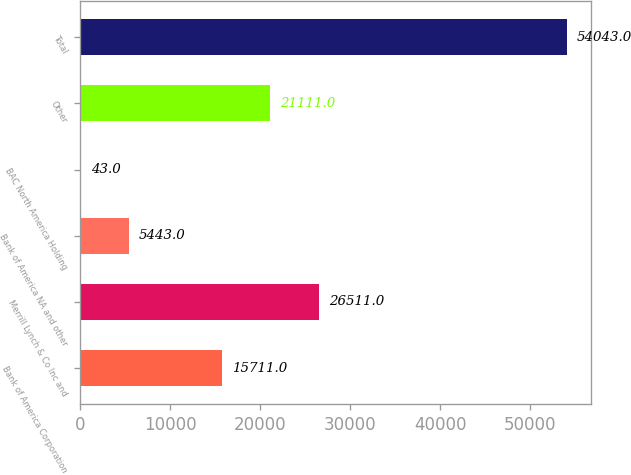Convert chart. <chart><loc_0><loc_0><loc_500><loc_500><bar_chart><fcel>Bank of America Corporation<fcel>Merrill Lynch & Co Inc and<fcel>Bank of America NA and other<fcel>BAC North America Holding<fcel>Other<fcel>Total<nl><fcel>15711<fcel>26511<fcel>5443<fcel>43<fcel>21111<fcel>54043<nl></chart> 